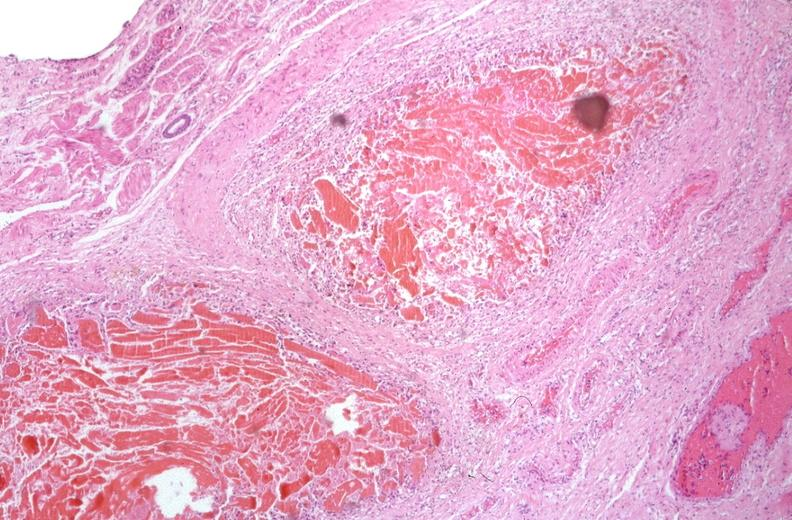s gastrointestinal present?
Answer the question using a single word or phrase. Yes 